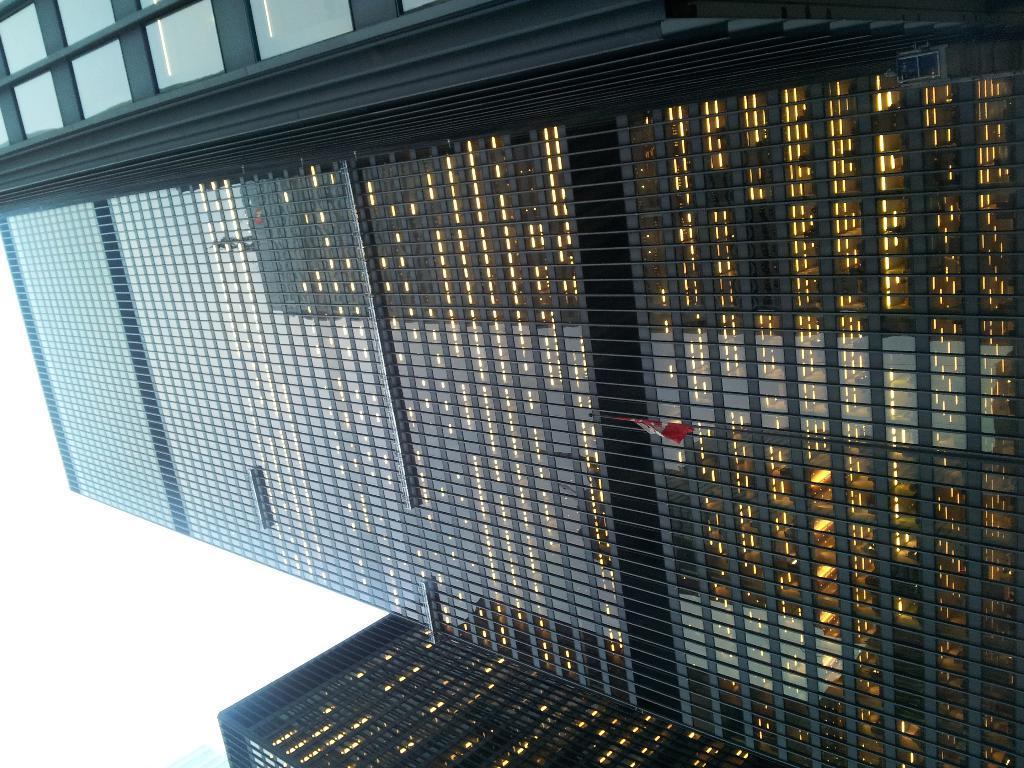In one or two sentences, can you explain what this image depicts? In this picture there are skyscrapers and buildings. The building have glass windows. Sky is cloudy. 